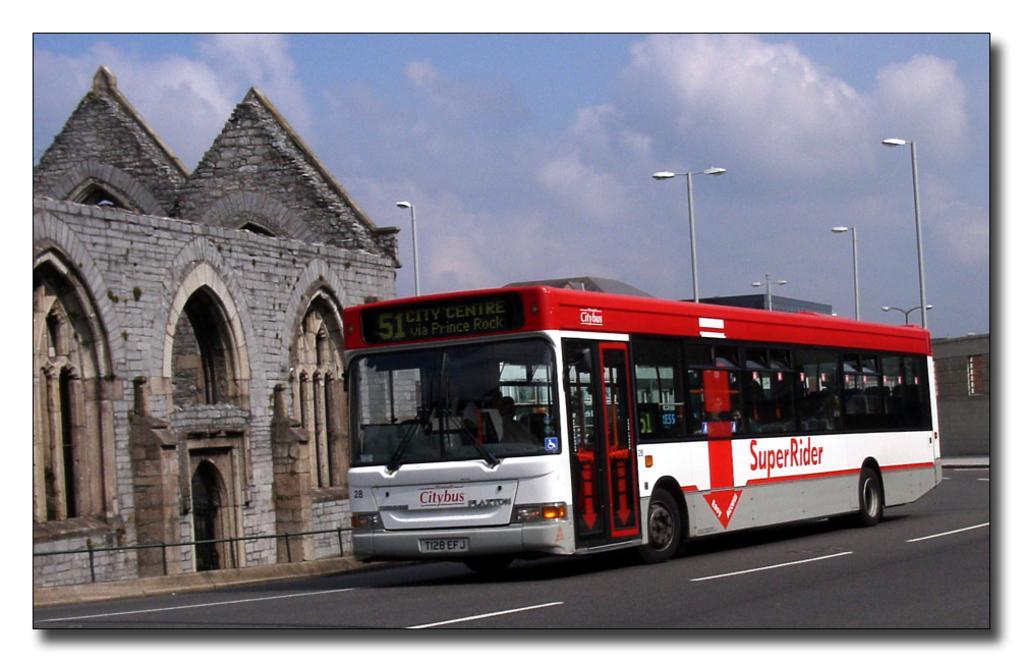Can you describe this image briefly? In this image there is a bus moving on the road, there are a few street lights and buildings. In the background there is the sky. 